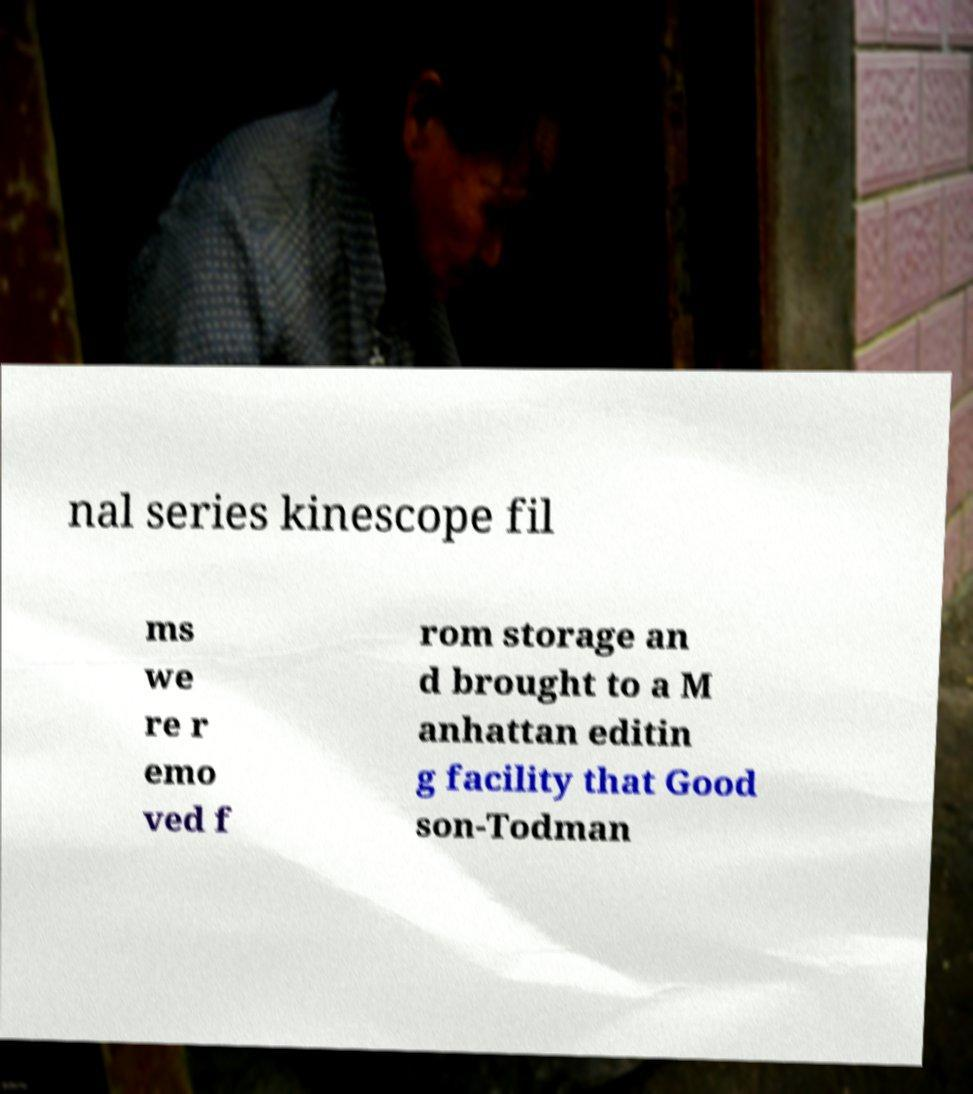Could you assist in decoding the text presented in this image and type it out clearly? nal series kinescope fil ms we re r emo ved f rom storage an d brought to a M anhattan editin g facility that Good son-Todman 